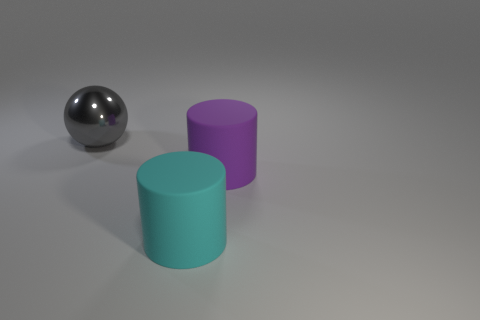Add 1 purple cylinders. How many objects exist? 4 Subtract all cylinders. How many objects are left? 1 Subtract all large cyan things. Subtract all yellow shiny balls. How many objects are left? 2 Add 3 large cylinders. How many large cylinders are left? 5 Add 1 rubber objects. How many rubber objects exist? 3 Subtract 0 purple balls. How many objects are left? 3 